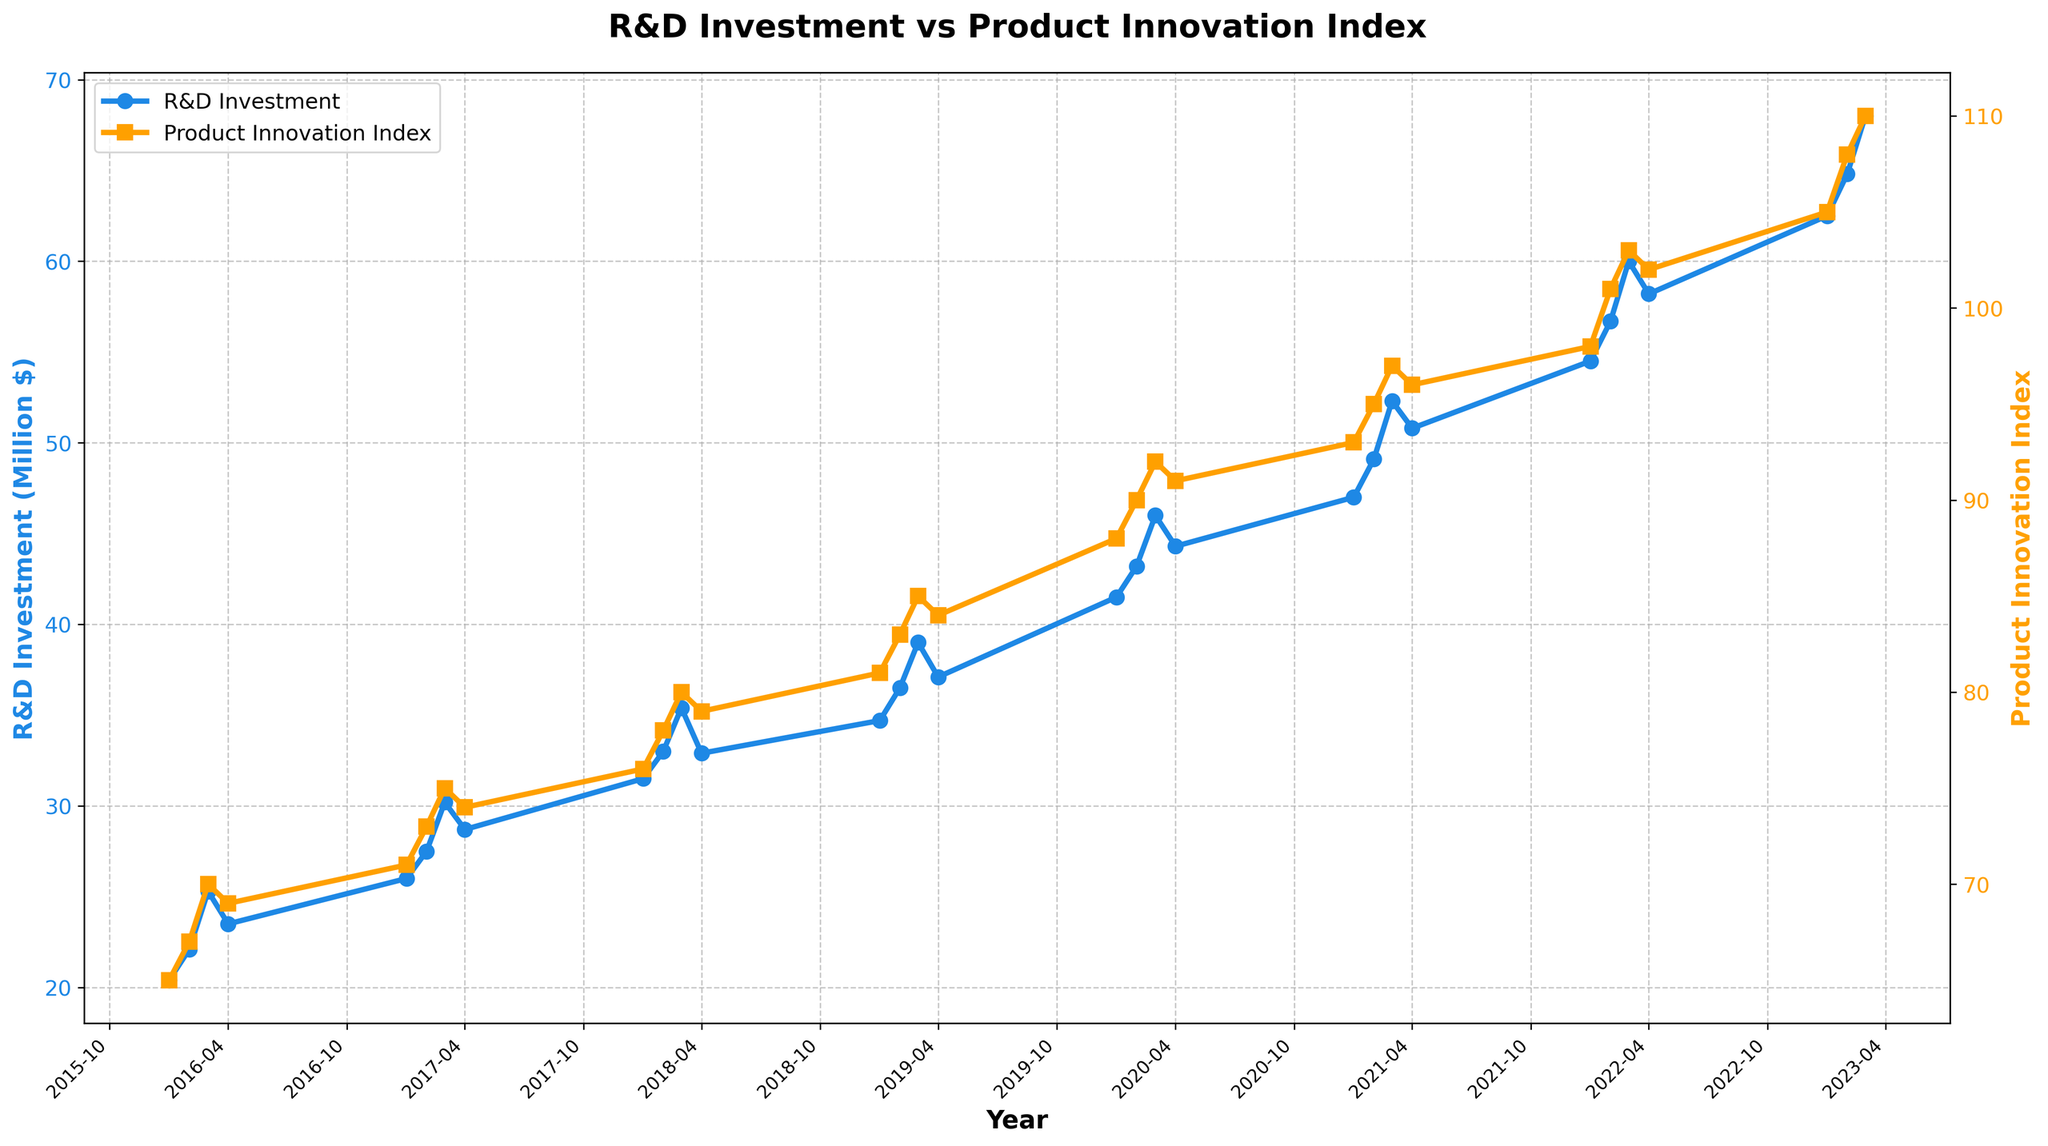What's the title of the figure? The title of the figure is displayed prominently at the top of the plot. It states, "R&D Investment vs Product Innovation Index".
Answer: R&D Investment vs Product Innovation Index How many data points are shown in the figure for each time series? The data spans from Q1 2016 to Q3 2023. For each quarter, there is a data point, cumulating to 31 data points for both the R&D Investment and Product Innovation Index time series.
Answer: 31 What are the colors used for the R&D Investment and Product Innovation Index lines? The color of the R&D Investment line is blue and the Product Innovation Index line is orange. This can be observed from the colors of the lines and the corresponding Y-axis labels.
Answer: Blue and orange Which quarter shows the highest R&D Investment? By examining the peaks in the blue line on the plot, the highest R&D Investment can be seen in Q3 2023 at approximately 68.0 million dollars.
Answer: Q3 2023 In which quarter did the Product Innovation Index first reach 100 or more? By following the orange line, we see that the index first reaches 101 in Q2 2022.
Answer: Q2 2022 What is the difference in R&D Investment between the start and the end of the period? The R&D investment in Q1 2016 is 20.4 million while in Q3 2023 it is 68.0 million. The difference is 68.0 - 20.4 = 47.6 million.
Answer: 47.6 million Was there any period where the Product Innovation Index decreased over consecutive quarters? By tracing the orange line, we observe a slight decrease between Q3 2021 (97) and Q4 2021 (96) and again between Q3 2022 (103) and Q4 2022 (102).
Answer: Yes How does the trend in R&D Investment compare to the trend in the Product Innovation Index over the seven years? Both the R&D Investment and Product Innovation Index show an overall upward trend from 2016 to 2023, although there are some fluctuations within each year. Generally, as R&D Investment increases, the Product Innovation Index also increases.
Answer: Both trends are upward What period shows the fastest growth in the Product Innovation Index? The fastest growth in the Product Innovation Index appears between Q1 2016 and Q2 2016, moving from 65 to 67 in a short period.
Answer: Q1 2016 to Q2 2016 